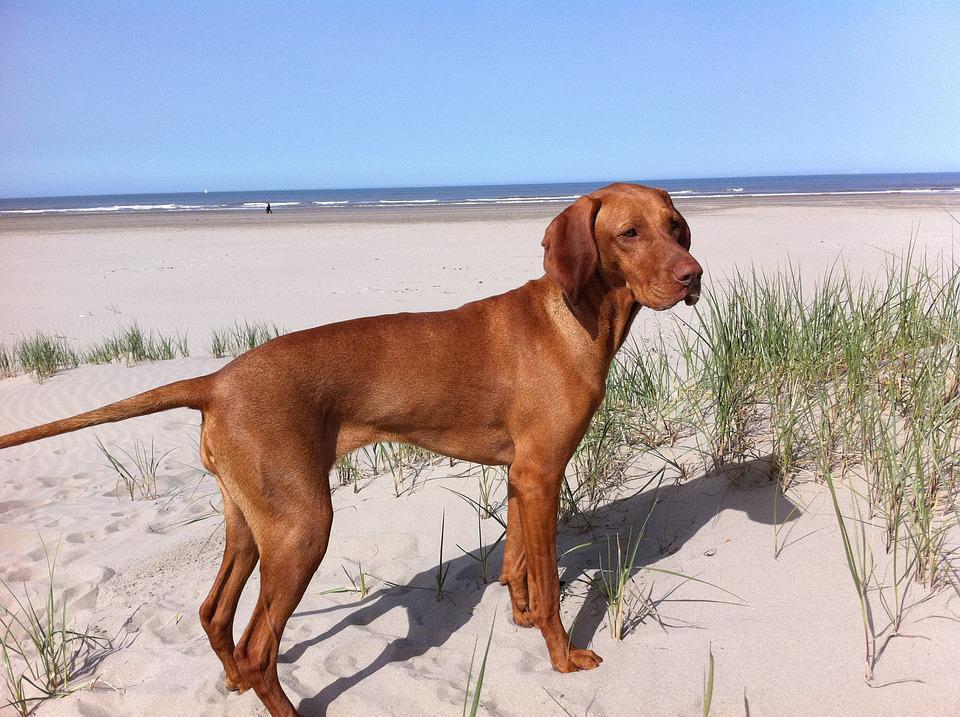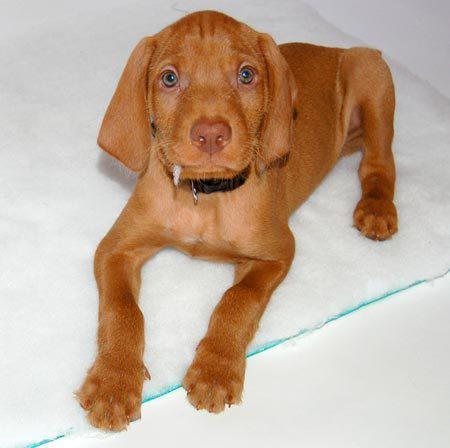The first image is the image on the left, the second image is the image on the right. Analyze the images presented: Is the assertion "One image shows a rightward-turned dog standing in profile with his tail out straight, and the other image features one puppy in a non-standing pose." valid? Answer yes or no. Yes. The first image is the image on the left, the second image is the image on the right. Evaluate the accuracy of this statement regarding the images: "At least two dogs are outside.". Is it true? Answer yes or no. No. 